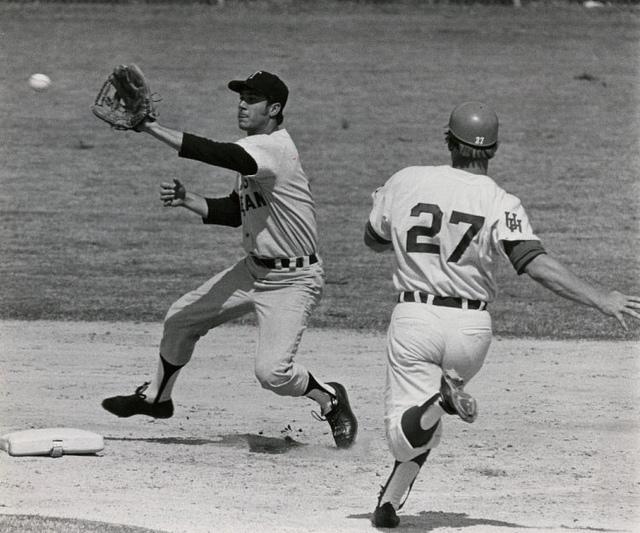What number is on his jersey?
Quick response, please. 27. Where are the players?
Be succinct. On field. Is this man a southpaw?
Concise answer only. Yes. What is the man doing?
Answer briefly. Running. What type of hat is the man wearing?
Give a very brief answer. Cap. What number is on the boy's uniform?
Be succinct. 27. What is this person doing?
Give a very brief answer. Playing baseball. Are the men wearing gloves right handed?
Answer briefly. No. What base is this?
Answer briefly. Second. Do these guys like each other?
Quick response, please. No. How many players are in the picture?
Answer briefly. 2. What do the shirts say?
Be succinct. 27. What number is on the players shirt?
Be succinct. 27. What game is being played?
Quick response, please. Baseball. Is this picture in color or black and white?
Short answer required. Black and white. Is the pitcher left or right handed?
Quick response, please. Right. What is the man called who has a glove on his left hand?
Be succinct. Catcher. Will he be tagged out?
Quick response, please. Yes. 